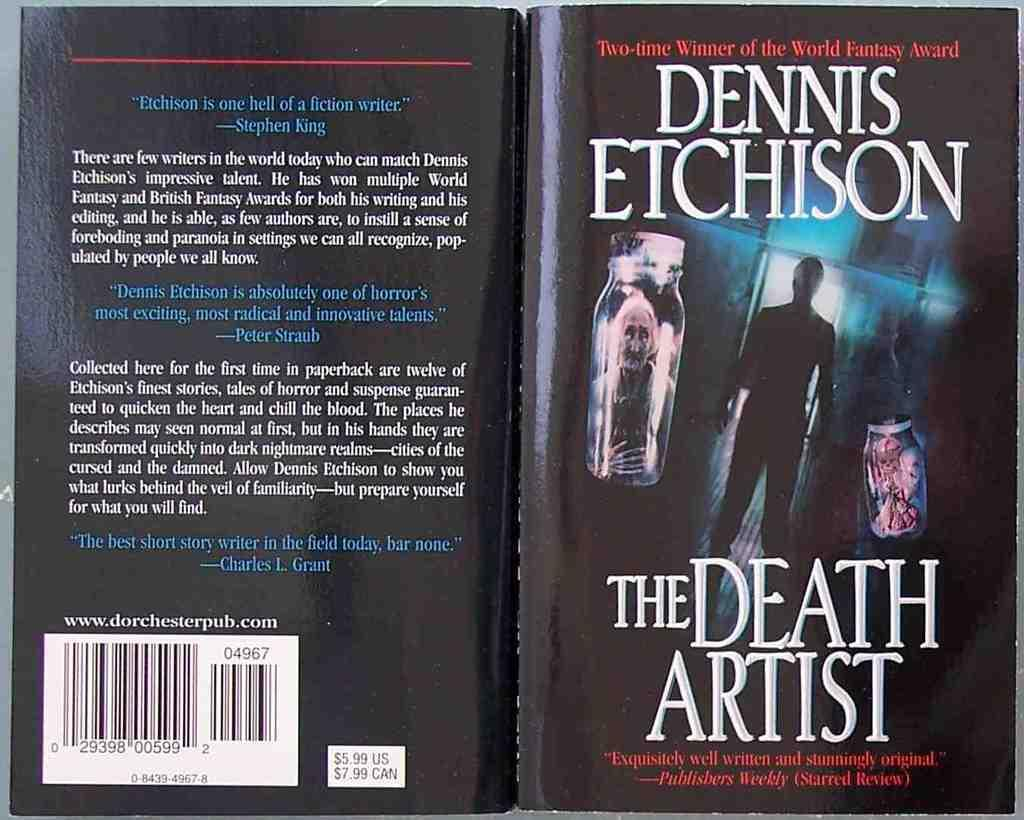<image>
Describe the image concisely. A Dennis Etchison novel called the Death Artist. 